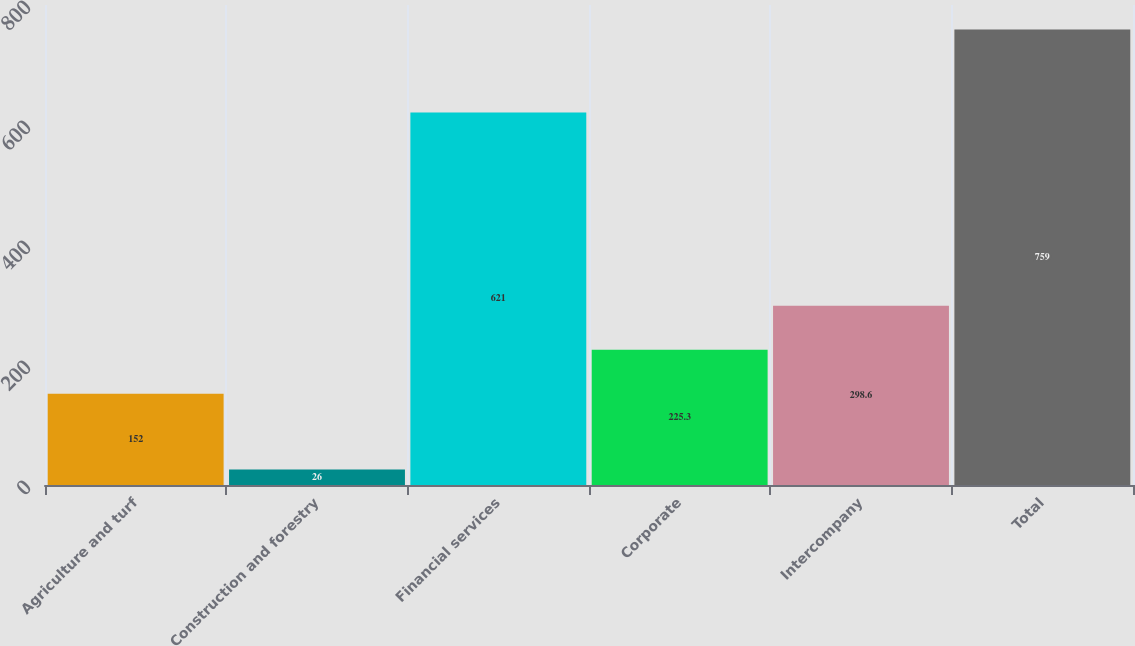Convert chart to OTSL. <chart><loc_0><loc_0><loc_500><loc_500><bar_chart><fcel>Agriculture and turf<fcel>Construction and forestry<fcel>Financial services<fcel>Corporate<fcel>Intercompany<fcel>Total<nl><fcel>152<fcel>26<fcel>621<fcel>225.3<fcel>298.6<fcel>759<nl></chart> 